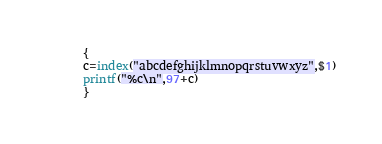<code> <loc_0><loc_0><loc_500><loc_500><_Awk_>{
c=index("abcdefghijklmnopqrstuvwxyz",$1)
printf("%c\n",97+c)
}
</code> 